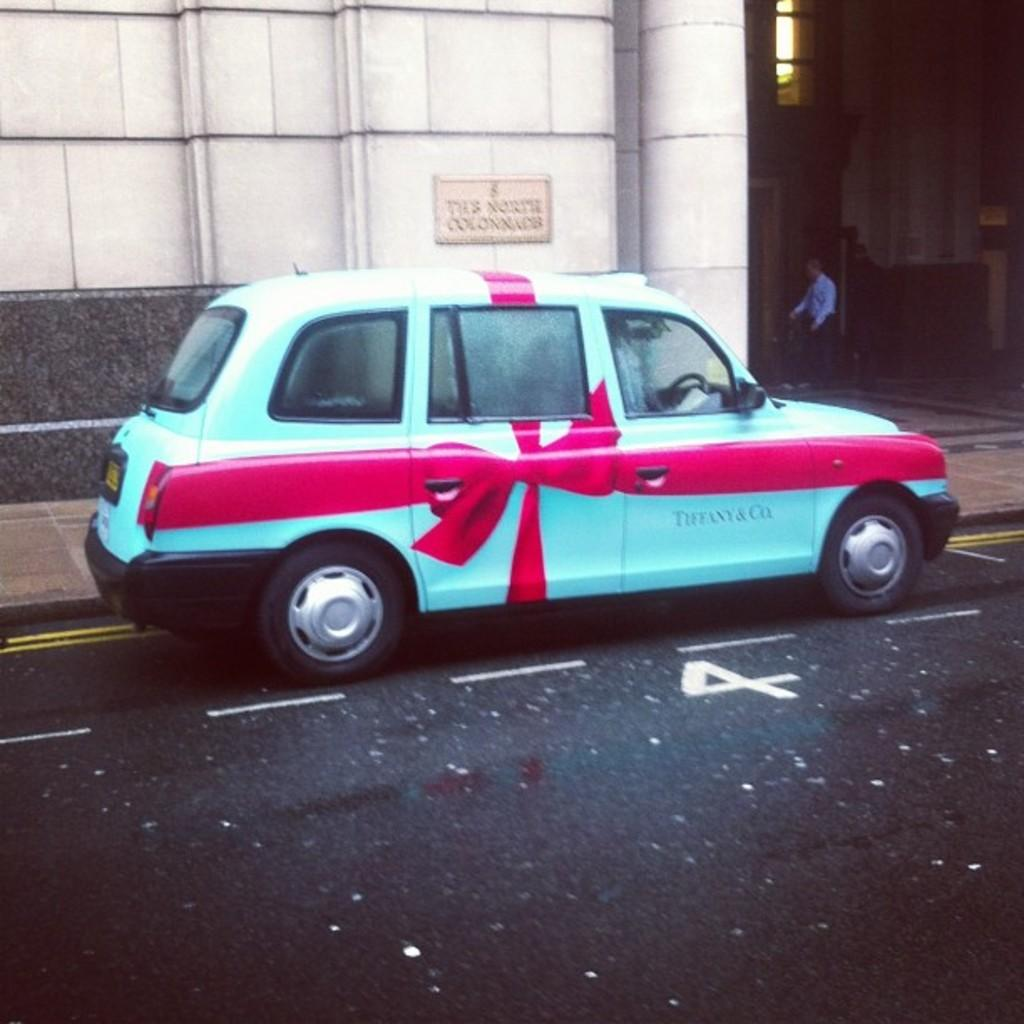What is on the road in the image? There is a vehicle on the road in the image. Can you describe the person in the image? There is a person standing in the image. What can be seen in the background of the image? There is a building in the background of the image. What type of quill is the person holding in the image? There is no quill present in the image; the person is simply standing. Is there a camp visible in the image? No, there is no camp present in the image. 